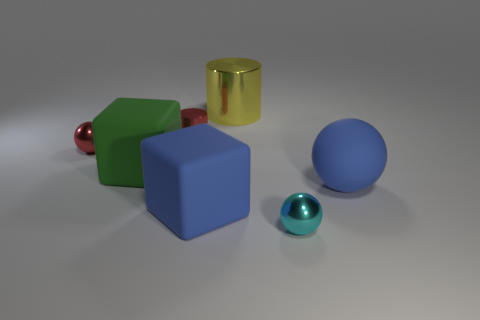How many balls are behind the big blue matte cube and to the right of the yellow cylinder?
Offer a very short reply. 1. What is the color of the tiny ball that is on the right side of the metallic ball that is behind the tiny ball right of the red ball?
Your answer should be compact. Cyan. There is a cylinder that is in front of the big yellow cylinder; how many small red shiny spheres are in front of it?
Offer a very short reply. 1. How many other things are there of the same shape as the cyan shiny thing?
Give a very brief answer. 2. How many objects are either rubber objects or rubber objects that are in front of the large green matte object?
Provide a succinct answer. 3. Is the number of metal spheres that are behind the big blue ball greater than the number of cyan objects that are on the left side of the red cylinder?
Offer a terse response. Yes. What is the shape of the tiny shiny object in front of the small metal thing on the left side of the small red shiny object on the right side of the small red shiny ball?
Provide a short and direct response. Sphere. There is a big blue object that is to the left of the blue rubber sphere that is behind the cyan sphere; what shape is it?
Keep it short and to the point. Cube. Are there any cyan cylinders that have the same material as the large green thing?
Give a very brief answer. No. There is a block that is the same color as the rubber sphere; what size is it?
Give a very brief answer. Large. 